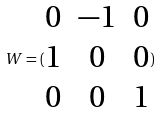<formula> <loc_0><loc_0><loc_500><loc_500>W = ( \begin{matrix} 0 & - 1 & 0 \\ 1 & 0 & 0 \\ 0 & 0 & 1 \end{matrix} )</formula> 